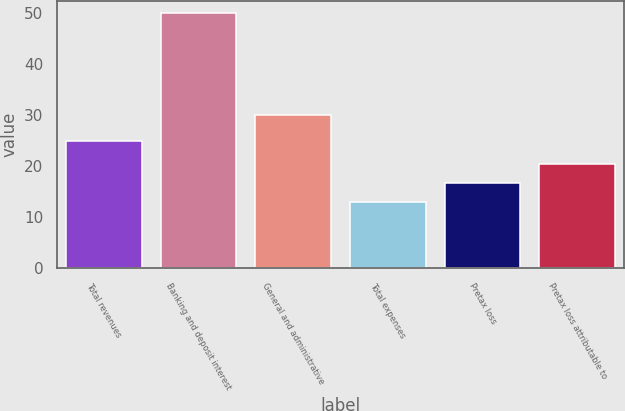Convert chart to OTSL. <chart><loc_0><loc_0><loc_500><loc_500><bar_chart><fcel>Total revenues<fcel>Banking and deposit interest<fcel>General and administrative<fcel>Total expenses<fcel>Pretax loss<fcel>Pretax loss attributable to<nl><fcel>25<fcel>50<fcel>30<fcel>13<fcel>16.7<fcel>20.4<nl></chart> 